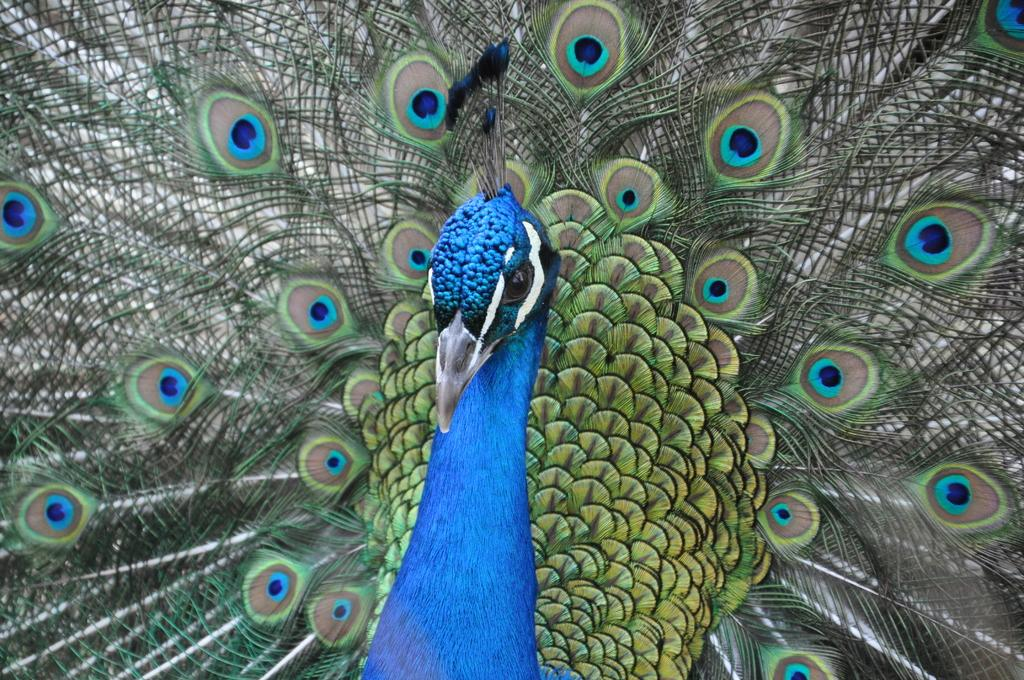What type of animal is in the picture? There is a peacock in the picture. What colors can be seen on the peacock? The peacock has blue, green, and brown colors. How many holes are visible in the picture? There are no holes visible in the picture; it features a peacock with blue, green, and brown colors. Can you tell me how the peacock is helping someone in the image? The peacock is not helping anyone in the image; it is simply a bird with blue, green, and brown colors. 